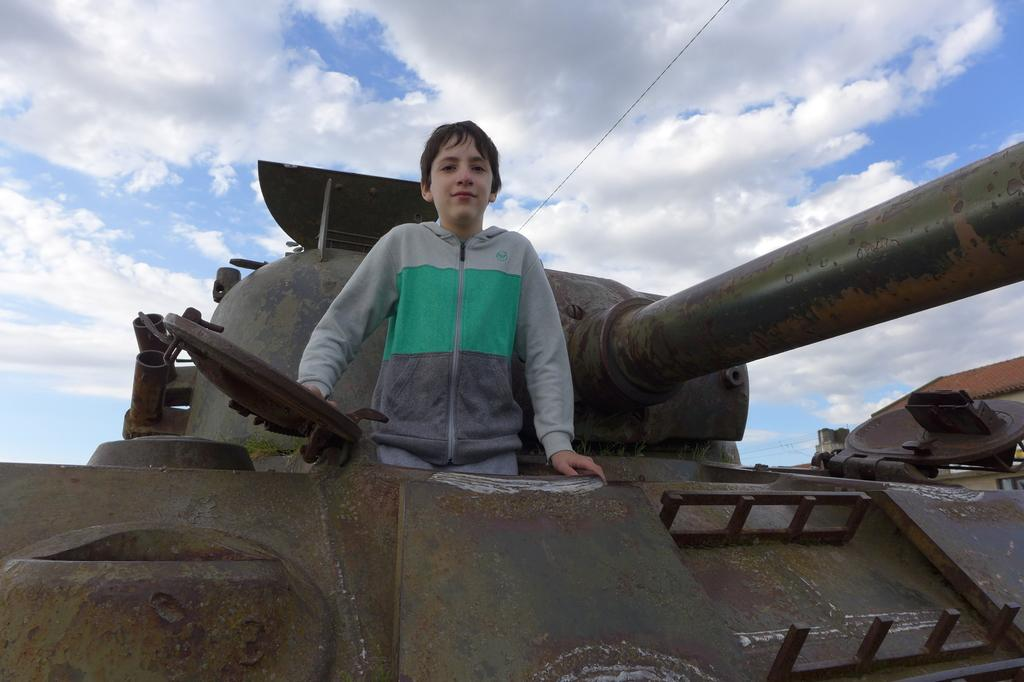What is the main subject in the middle of the image? The main subject in the middle of the image is an army tanker. What is the kid doing in the image? The kid is standing on the army tanker. What can be seen in the background of the image? There is a cloudy sky in the background of the image. What type of bike is the kid riding in the image? There is no bike present in the image; the kid is standing on an army tanker. How much sugar is visible in the image? There is no sugar present in the image. 